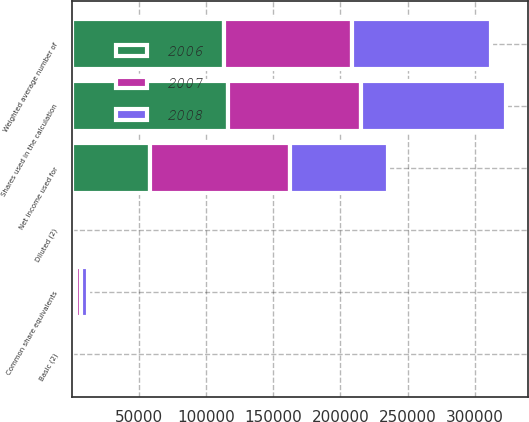Convert chart to OTSL. <chart><loc_0><loc_0><loc_500><loc_500><stacked_bar_chart><ecel><fcel>Net income used for<fcel>Weighted average number of<fcel>Common share equivalents<fcel>Shares used in the calculation<fcel>Basic (2)<fcel>Diluted (2)<nl><fcel>2007<fcel>103871<fcel>95246<fcel>3782<fcel>99028<fcel>1.09<fcel>1.05<nl><fcel>2008<fcel>73553<fcel>103613<fcel>4715<fcel>108328<fcel>0.71<fcel>0.68<nl><fcel>2006<fcel>58192<fcel>113071<fcel>3132<fcel>116203<fcel>0.51<fcel>0.5<nl></chart> 